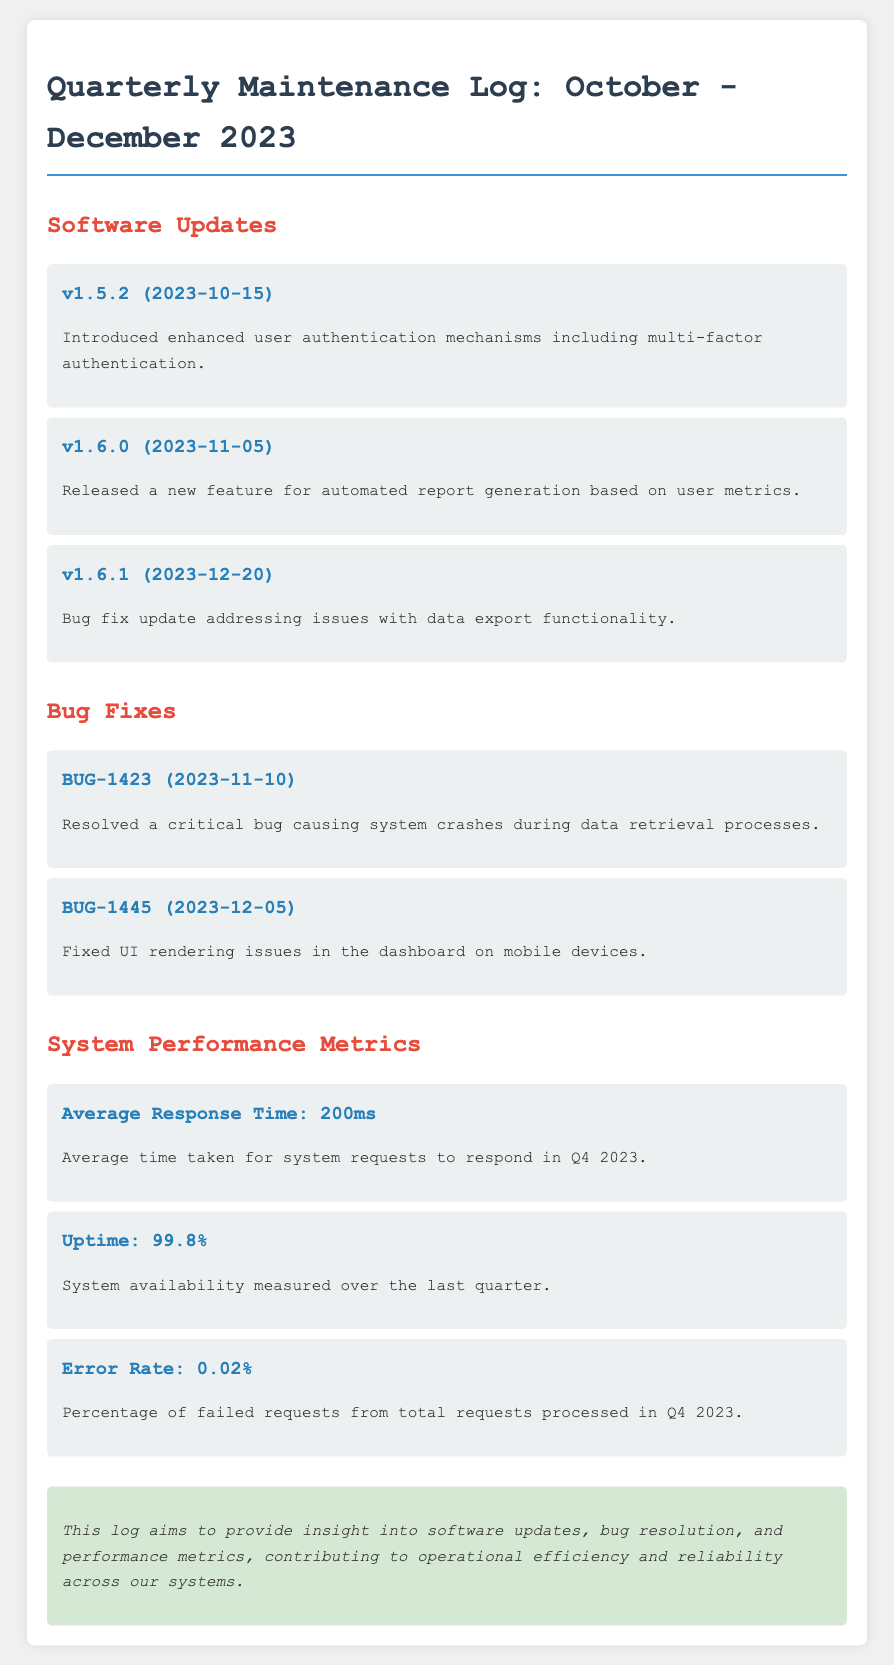what is the title of the document? The title of the document is prominently displayed at the top of the rendered page.
Answer: Quarterly Maintenance Log: October - December 2023 what was introduced in v1.5.2? The update v1.5.2 details a specific enhancement mentioned in the document.
Answer: enhanced user authentication mechanisms when was the bug BUG-1423 resolved? The date when the bug was resolved is included next to the bug entry in the document.
Answer: 2023-11-10 what is the uptime percentage for Q4 2023? The uptime metric is explicitly stated in the performance metrics section.
Answer: 99.8% what feature was released in v1.6.0? The feature added in the update is explicitly mentioned under software updates.
Answer: automated report generation what is the average response time? The average response time is listed in the system performance metrics section.
Answer: 200ms how many bug fixes are listed in the document? The number of bug fixes can be counted from the bug fixes section.
Answer: 2 what percentage of failed requests is reported? The error rate is provided in the system performance metrics.
Answer: 0.02% 